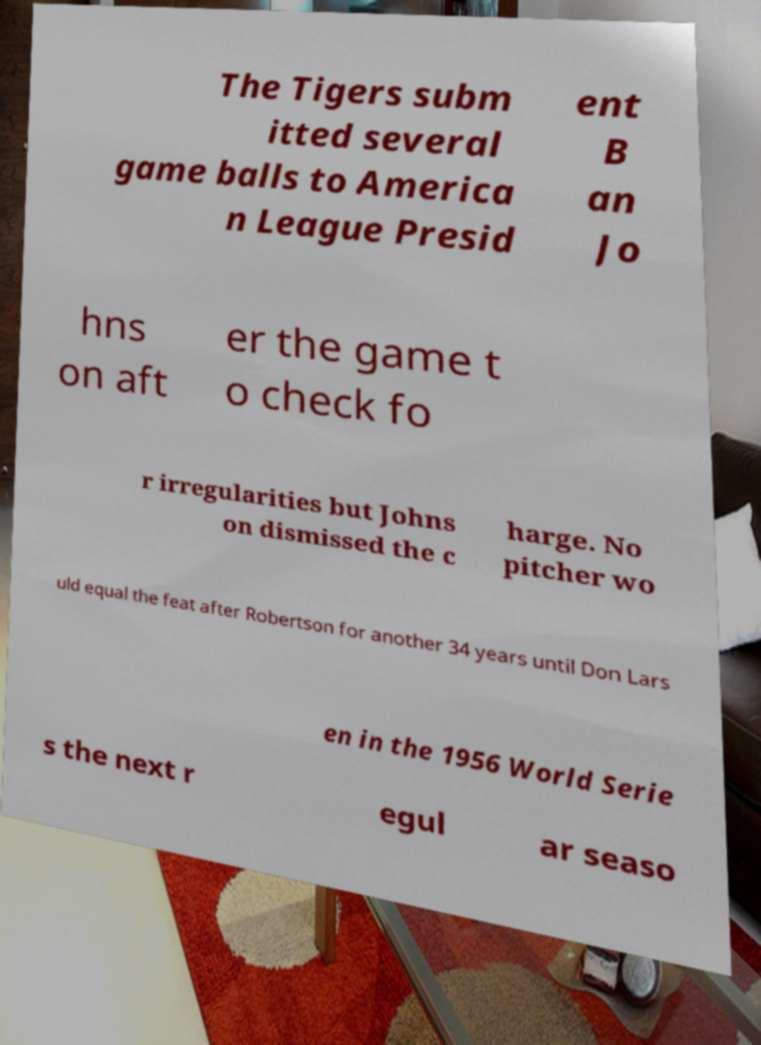For documentation purposes, I need the text within this image transcribed. Could you provide that? The Tigers subm itted several game balls to America n League Presid ent B an Jo hns on aft er the game t o check fo r irregularities but Johns on dismissed the c harge. No pitcher wo uld equal the feat after Robertson for another 34 years until Don Lars en in the 1956 World Serie s the next r egul ar seaso 